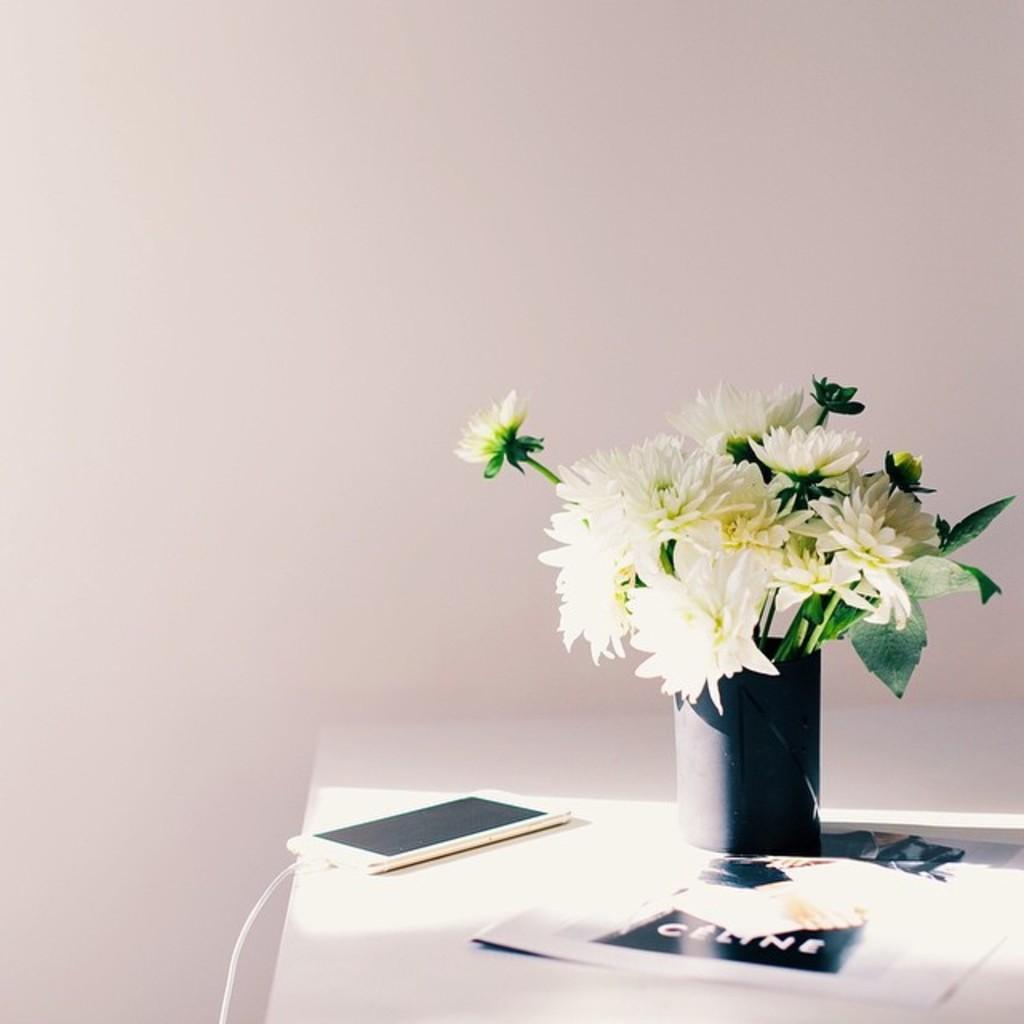Can you describe this image briefly? In the image we can see there is a table on which there is a vase and in it there are flowers and there is a mobile phone. 